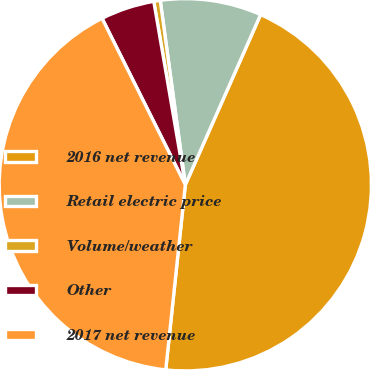<chart> <loc_0><loc_0><loc_500><loc_500><pie_chart><fcel>2016 net revenue<fcel>Retail electric price<fcel>Volume/weather<fcel>Other<fcel>2017 net revenue<nl><fcel>45.05%<fcel>8.78%<fcel>0.56%<fcel>4.67%<fcel>40.94%<nl></chart> 